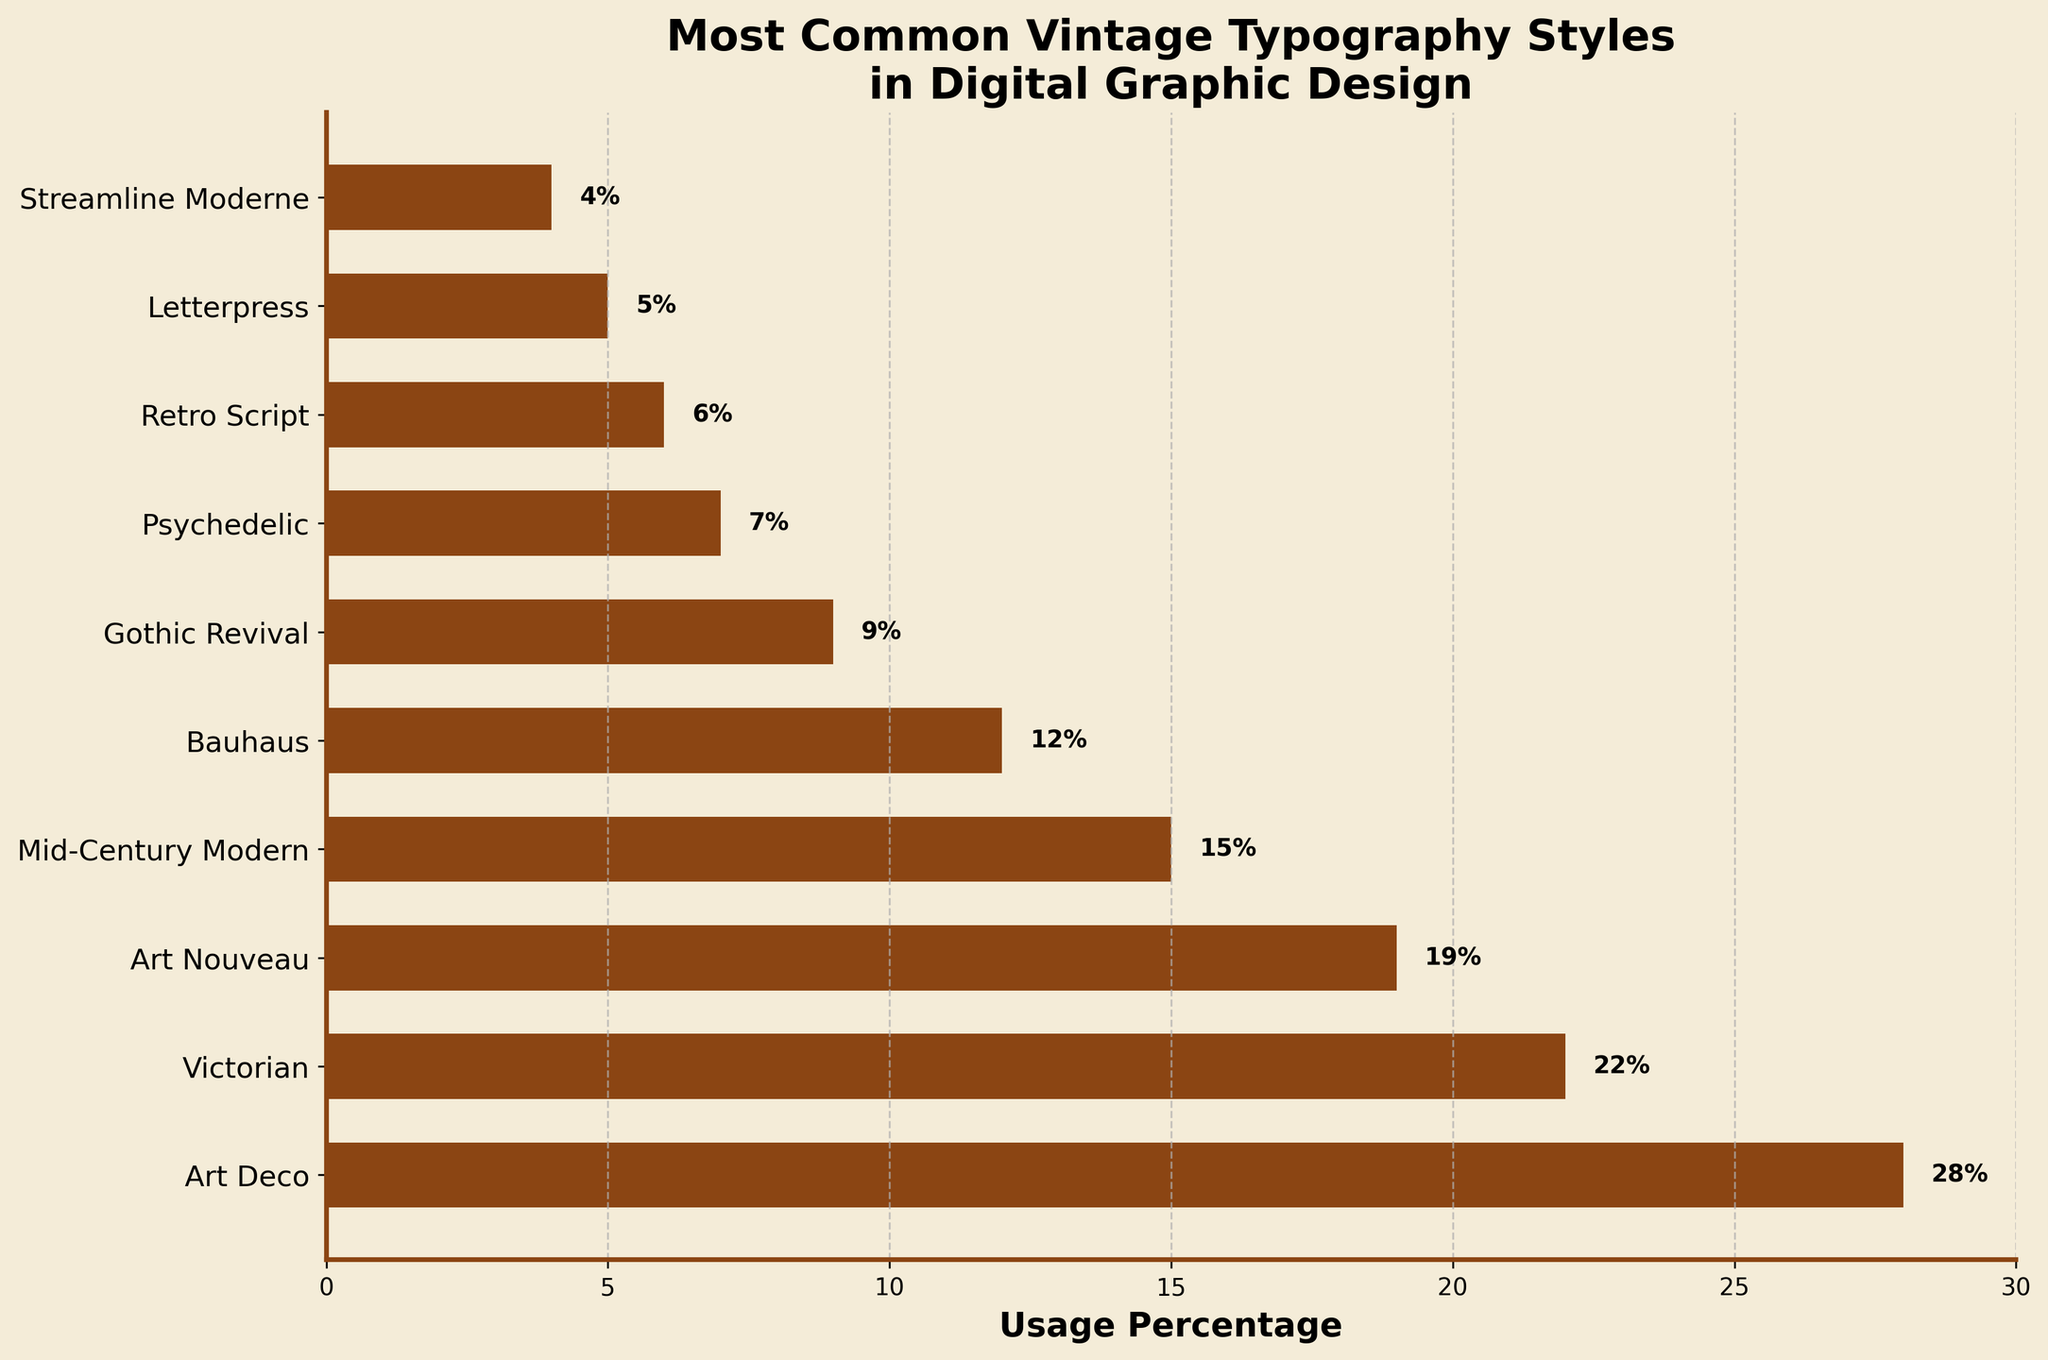Which vintage typography style is the most commonly used in digital graphic design according to the figure? The figure shows the "Usage Percentage" for each style; Art Deco has the highest value at 28%.
Answer: Art Deco How much more common is Art Deco compared to Victorian? Subtract the usage percentage of Victorian (22%) from that of Art Deco (28%). 28% - 22% = 6%
Answer: 6% What is the total usage percentage of the least three common styles? Sum the usage percentages of Streamline Moderne (4%), Letterpress (5%), and Retro Script (6%). 4% + 5% + 6% = 15%
Answer: 15% Which style is exactly in the middle in terms of usage percentage? Sort the styles based on their usage percentages: 
Streamline Moderne (4%), Letterpress (5%), Retro Script (6%), Psychedelic (7%), Gothic Revival (9%), Bauhaus (12%), Mid-Century Modern (15%), Art Nouveau (19%), Victorian (22%), Art Deco (28%). 
The middle value in this list is Bauhaus (12%).
Answer: Bauhaus Are Art Nouveau and Mid-Century Modern styles used equally? Compare the usage percentages. Art Nouveau is at 19%, while Mid-Century Modern is at 15%. They are not equal.
Answer: No Which style has a usage percentage closest to but not exceeding 10%? Review the styles' usage percentages and find the one closest to 10% but not exceeding: Gothic Revival at 9%.
Answer: Gothic Revival How much less common is the Bauhaus style compared to the Art Nouveau style? Subtract Bauhaus's usage percentage (12%) from Art Nouveau's (19%). 19% - 12% = 7%
Answer: 7% What is the combined usage percentage of the top two styles? Add the usage percentages of Art Deco (28%) and Victorian (22%). 28% + 22% = 50%
Answer: 50% How many styles have usage percentages greater than the Bauhaus style? Count the number of styles with percentages greater than Bauhaus's 12%: Art Deco (28%), Victorian (22%), Art Nouveau (19%), Mid-Century Modern (15%). There are four such styles.
Answer: 4 Which style has the lowest usage percentage and what is it? The figure shows that Streamline Moderne has the lowest usage percentage at 4%.
Answer: Streamline Moderne at 4% 